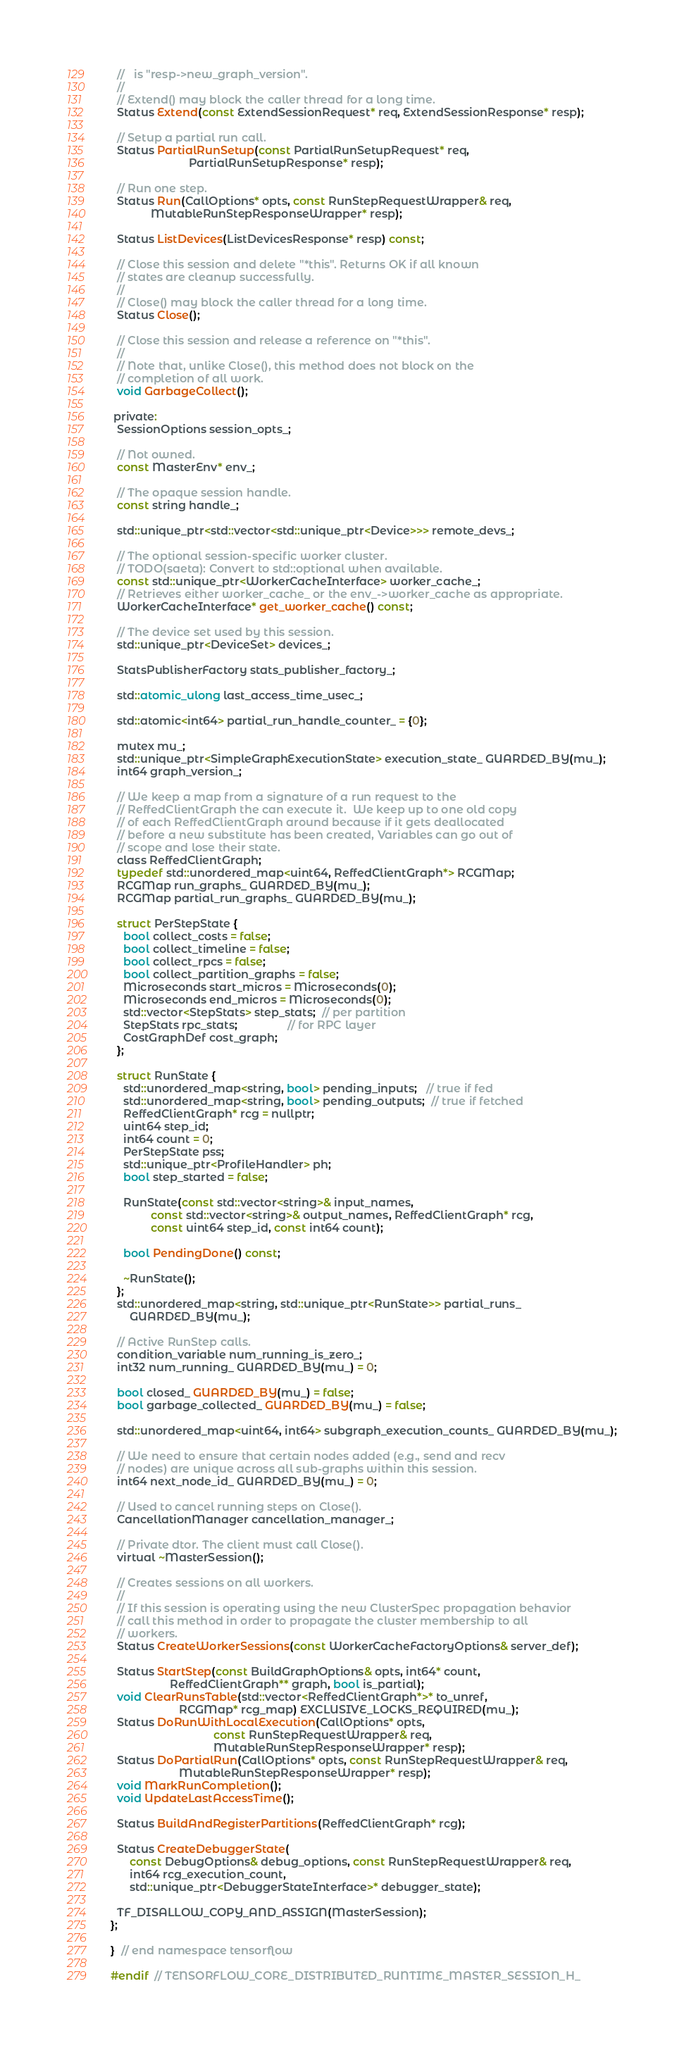<code> <loc_0><loc_0><loc_500><loc_500><_C_>  //   is "resp->new_graph_version".
  //
  // Extend() may block the caller thread for a long time.
  Status Extend(const ExtendSessionRequest* req, ExtendSessionResponse* resp);

  // Setup a partial run call.
  Status PartialRunSetup(const PartialRunSetupRequest* req,
                         PartialRunSetupResponse* resp);

  // Run one step.
  Status Run(CallOptions* opts, const RunStepRequestWrapper& req,
             MutableRunStepResponseWrapper* resp);

  Status ListDevices(ListDevicesResponse* resp) const;

  // Close this session and delete "*this". Returns OK if all known
  // states are cleanup successfully.
  //
  // Close() may block the caller thread for a long time.
  Status Close();

  // Close this session and release a reference on "*this".
  //
  // Note that, unlike Close(), this method does not block on the
  // completion of all work.
  void GarbageCollect();

 private:
  SessionOptions session_opts_;

  // Not owned.
  const MasterEnv* env_;

  // The opaque session handle.
  const string handle_;

  std::unique_ptr<std::vector<std::unique_ptr<Device>>> remote_devs_;

  // The optional session-specific worker cluster.
  // TODO(saeta): Convert to std::optional when available.
  const std::unique_ptr<WorkerCacheInterface> worker_cache_;
  // Retrieves either worker_cache_ or the env_->worker_cache as appropriate.
  WorkerCacheInterface* get_worker_cache() const;

  // The device set used by this session.
  std::unique_ptr<DeviceSet> devices_;

  StatsPublisherFactory stats_publisher_factory_;

  std::atomic_ulong last_access_time_usec_;

  std::atomic<int64> partial_run_handle_counter_ = {0};

  mutex mu_;
  std::unique_ptr<SimpleGraphExecutionState> execution_state_ GUARDED_BY(mu_);
  int64 graph_version_;

  // We keep a map from a signature of a run request to the
  // ReffedClientGraph the can execute it.  We keep up to one old copy
  // of each ReffedClientGraph around because if it gets deallocated
  // before a new substitute has been created, Variables can go out of
  // scope and lose their state.
  class ReffedClientGraph;
  typedef std::unordered_map<uint64, ReffedClientGraph*> RCGMap;
  RCGMap run_graphs_ GUARDED_BY(mu_);
  RCGMap partial_run_graphs_ GUARDED_BY(mu_);

  struct PerStepState {
    bool collect_costs = false;
    bool collect_timeline = false;
    bool collect_rpcs = false;
    bool collect_partition_graphs = false;
    Microseconds start_micros = Microseconds(0);
    Microseconds end_micros = Microseconds(0);
    std::vector<StepStats> step_stats;  // per partition
    StepStats rpc_stats;                // for RPC layer
    CostGraphDef cost_graph;
  };

  struct RunState {
    std::unordered_map<string, bool> pending_inputs;   // true if fed
    std::unordered_map<string, bool> pending_outputs;  // true if fetched
    ReffedClientGraph* rcg = nullptr;
    uint64 step_id;
    int64 count = 0;
    PerStepState pss;
    std::unique_ptr<ProfileHandler> ph;
    bool step_started = false;

    RunState(const std::vector<string>& input_names,
             const std::vector<string>& output_names, ReffedClientGraph* rcg,
             const uint64 step_id, const int64 count);

    bool PendingDone() const;

    ~RunState();
  };
  std::unordered_map<string, std::unique_ptr<RunState>> partial_runs_
      GUARDED_BY(mu_);

  // Active RunStep calls.
  condition_variable num_running_is_zero_;
  int32 num_running_ GUARDED_BY(mu_) = 0;

  bool closed_ GUARDED_BY(mu_) = false;
  bool garbage_collected_ GUARDED_BY(mu_) = false;

  std::unordered_map<uint64, int64> subgraph_execution_counts_ GUARDED_BY(mu_);

  // We need to ensure that certain nodes added (e.g., send and recv
  // nodes) are unique across all sub-graphs within this session.
  int64 next_node_id_ GUARDED_BY(mu_) = 0;

  // Used to cancel running steps on Close().
  CancellationManager cancellation_manager_;

  // Private dtor. The client must call Close().
  virtual ~MasterSession();

  // Creates sessions on all workers.
  //
  // If this session is operating using the new ClusterSpec propagation behavior
  // call this method in order to propagate the cluster membership to all
  // workers.
  Status CreateWorkerSessions(const WorkerCacheFactoryOptions& server_def);

  Status StartStep(const BuildGraphOptions& opts, int64* count,
                   ReffedClientGraph** graph, bool is_partial);
  void ClearRunsTable(std::vector<ReffedClientGraph*>* to_unref,
                      RCGMap* rcg_map) EXCLUSIVE_LOCKS_REQUIRED(mu_);
  Status DoRunWithLocalExecution(CallOptions* opts,
                                 const RunStepRequestWrapper& req,
                                 MutableRunStepResponseWrapper* resp);
  Status DoPartialRun(CallOptions* opts, const RunStepRequestWrapper& req,
                      MutableRunStepResponseWrapper* resp);
  void MarkRunCompletion();
  void UpdateLastAccessTime();

  Status BuildAndRegisterPartitions(ReffedClientGraph* rcg);

  Status CreateDebuggerState(
      const DebugOptions& debug_options, const RunStepRequestWrapper& req,
      int64 rcg_execution_count,
      std::unique_ptr<DebuggerStateInterface>* debugger_state);

  TF_DISALLOW_COPY_AND_ASSIGN(MasterSession);
};

}  // end namespace tensorflow

#endif  // TENSORFLOW_CORE_DISTRIBUTED_RUNTIME_MASTER_SESSION_H_
</code> 